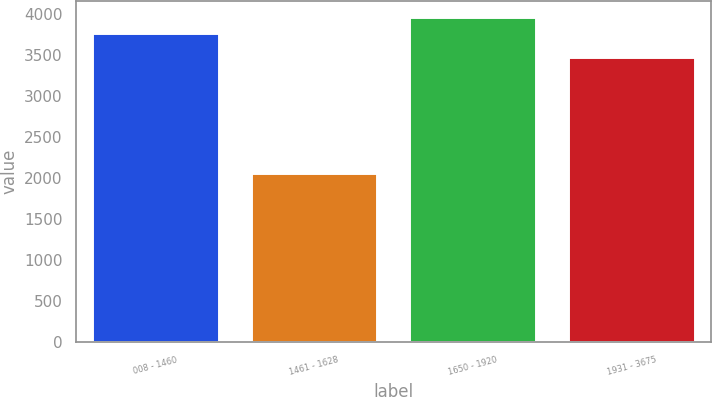Convert chart to OTSL. <chart><loc_0><loc_0><loc_500><loc_500><bar_chart><fcel>008 - 1460<fcel>1461 - 1628<fcel>1650 - 1920<fcel>1931 - 3675<nl><fcel>3770<fcel>2065<fcel>3957.4<fcel>3479<nl></chart> 